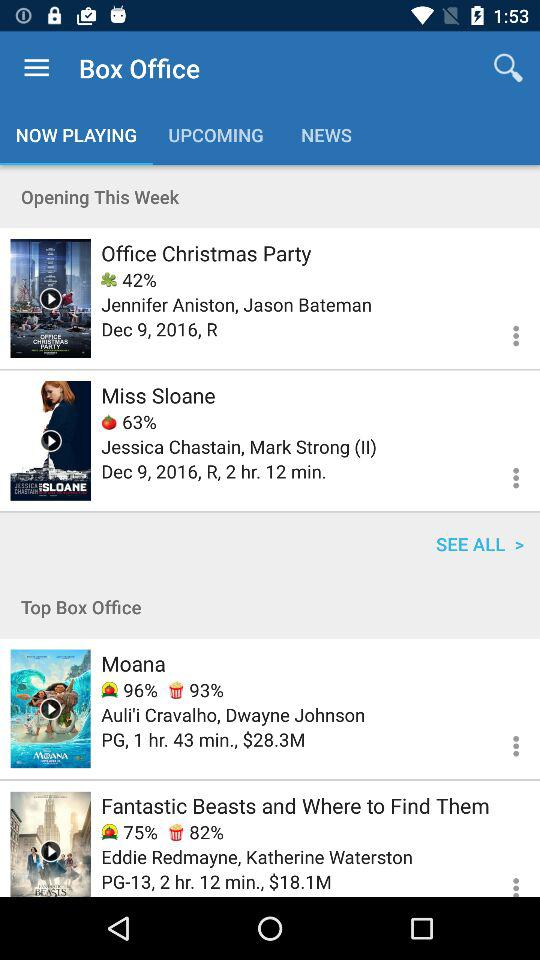How many movies are rated R?
Answer the question using a single word or phrase. 2 